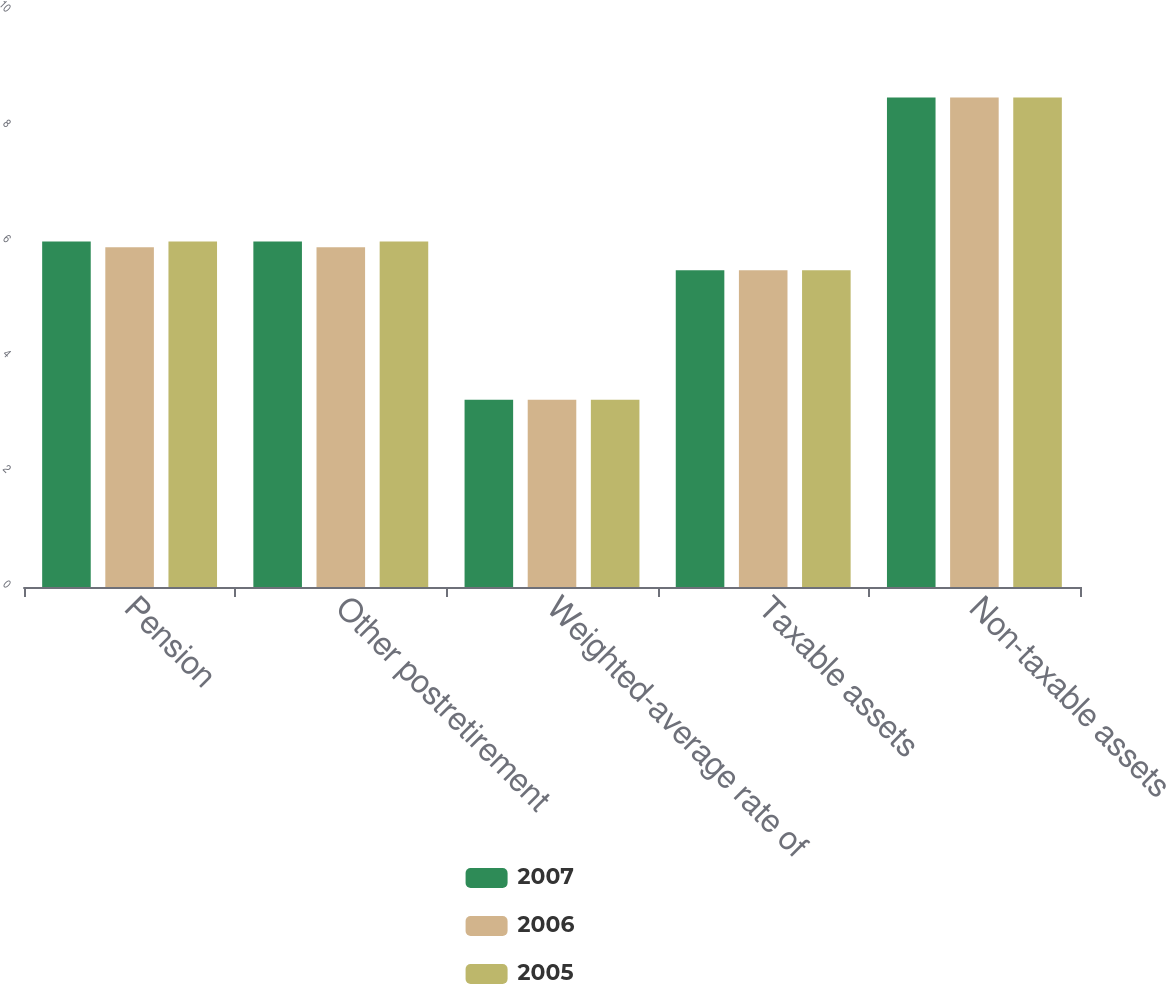<chart> <loc_0><loc_0><loc_500><loc_500><stacked_bar_chart><ecel><fcel>Pension<fcel>Other postretirement<fcel>Weighted-average rate of<fcel>Taxable assets<fcel>Non-taxable assets<nl><fcel>2007<fcel>6<fcel>6<fcel>3.25<fcel>5.5<fcel>8.5<nl><fcel>2006<fcel>5.9<fcel>5.9<fcel>3.25<fcel>5.5<fcel>8.5<nl><fcel>2005<fcel>6<fcel>6<fcel>3.25<fcel>5.5<fcel>8.5<nl></chart> 